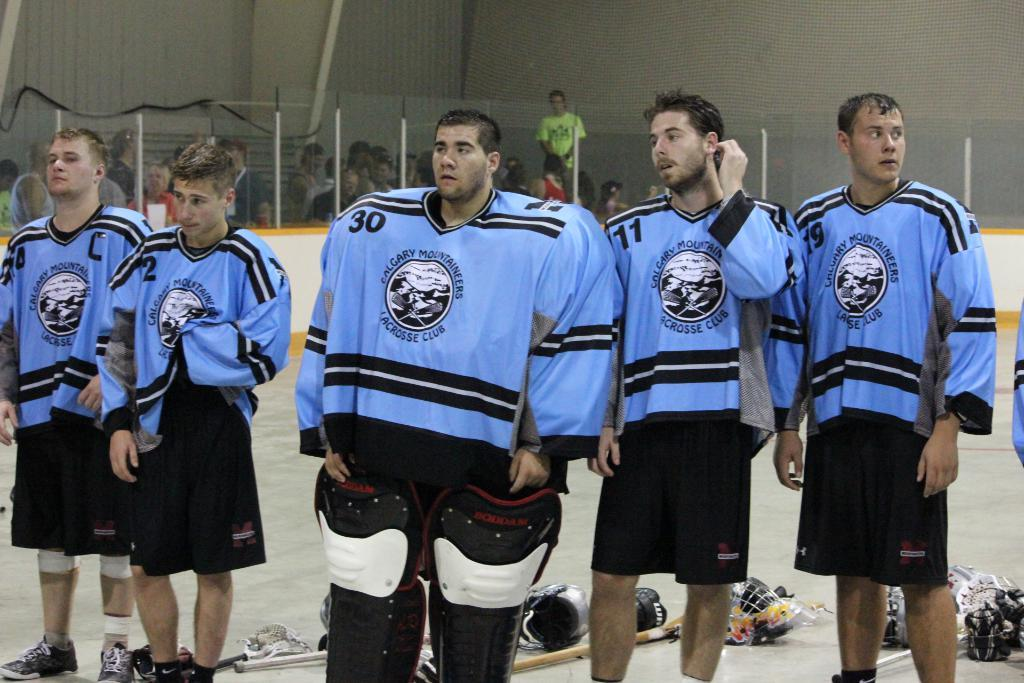<image>
Summarize the visual content of the image. Calgary ice hockey players stand together in a line. 